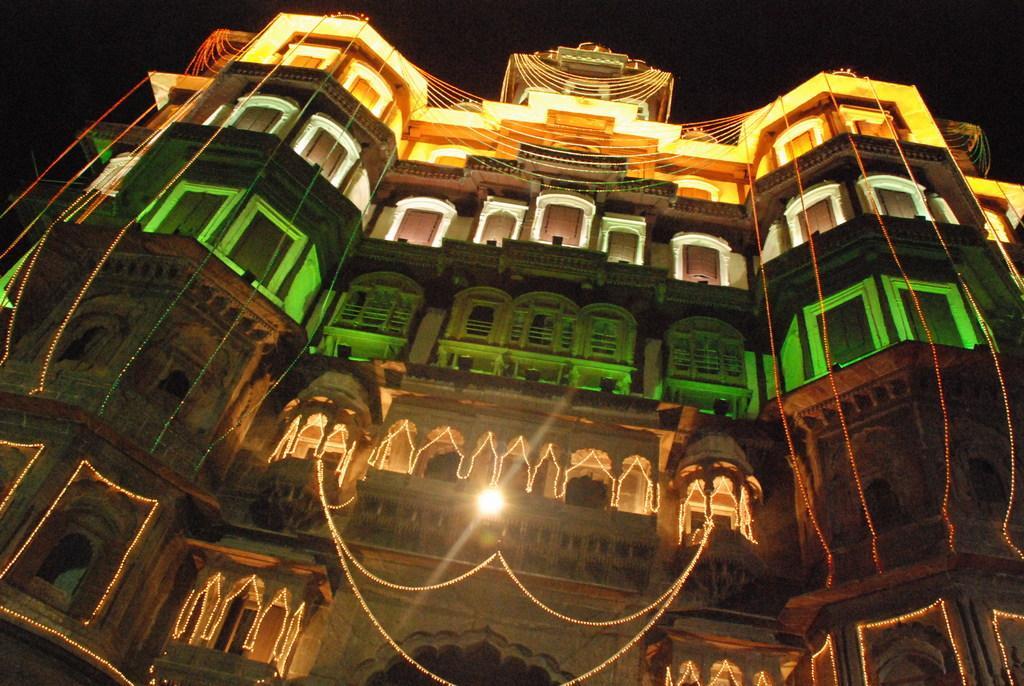Please provide a concise description of this image. In the picture we can see a historical building with full of lights to it and with some decoration lights to it and behind it we can see a sky which is dark. 